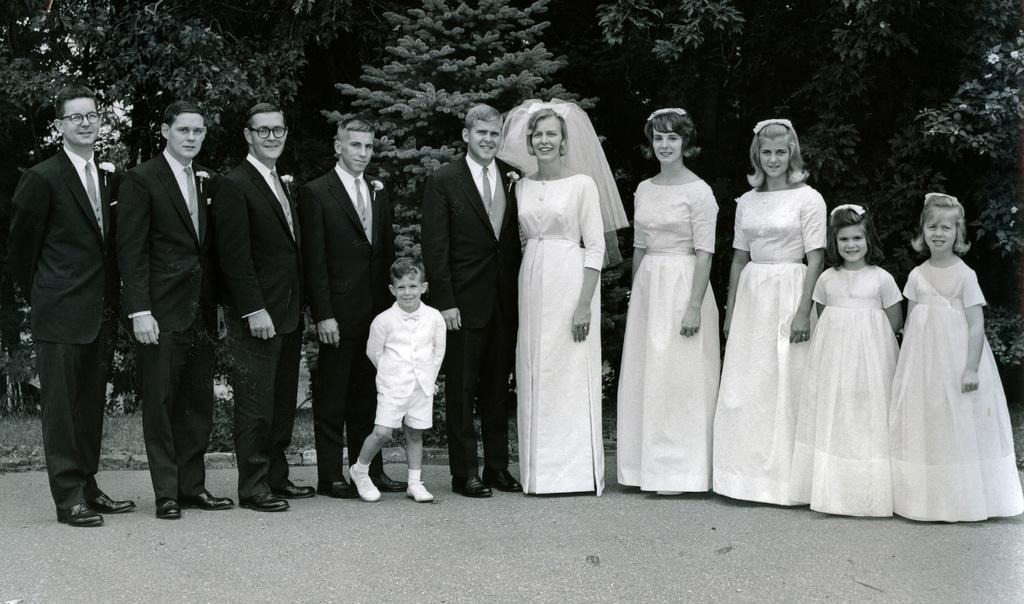In one or two sentences, can you explain what this image depicts? In this picture I can observe some people standing on the land. There are men, women and children in this picture. All of them are smiling. In the background there are trees. This is a black and white image. 